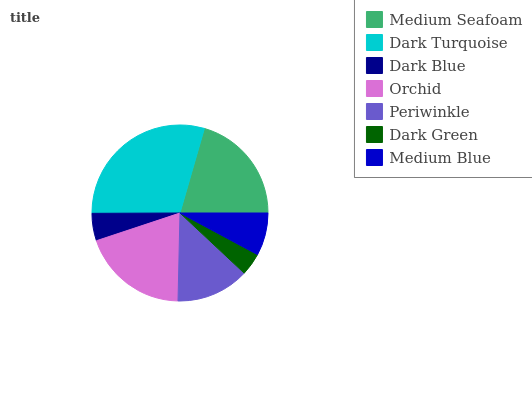Is Dark Green the minimum?
Answer yes or no. Yes. Is Dark Turquoise the maximum?
Answer yes or no. Yes. Is Dark Blue the minimum?
Answer yes or no. No. Is Dark Blue the maximum?
Answer yes or no. No. Is Dark Turquoise greater than Dark Blue?
Answer yes or no. Yes. Is Dark Blue less than Dark Turquoise?
Answer yes or no. Yes. Is Dark Blue greater than Dark Turquoise?
Answer yes or no. No. Is Dark Turquoise less than Dark Blue?
Answer yes or no. No. Is Periwinkle the high median?
Answer yes or no. Yes. Is Periwinkle the low median?
Answer yes or no. Yes. Is Orchid the high median?
Answer yes or no. No. Is Dark Blue the low median?
Answer yes or no. No. 